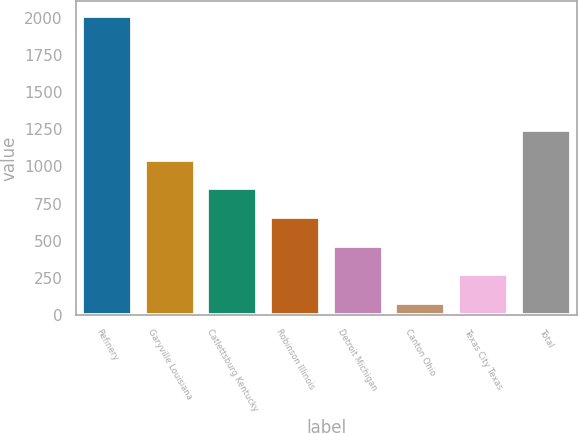Convert chart to OTSL. <chart><loc_0><loc_0><loc_500><loc_500><bar_chart><fcel>Refinery<fcel>Garyville Louisiana<fcel>Catlettsburg Kentucky<fcel>Robinson Illinois<fcel>Detroit Michigan<fcel>Canton Ohio<fcel>Texas City Texas<fcel>Total<nl><fcel>2012<fcel>1046<fcel>852.8<fcel>659.6<fcel>466.4<fcel>80<fcel>273.2<fcel>1248<nl></chart> 